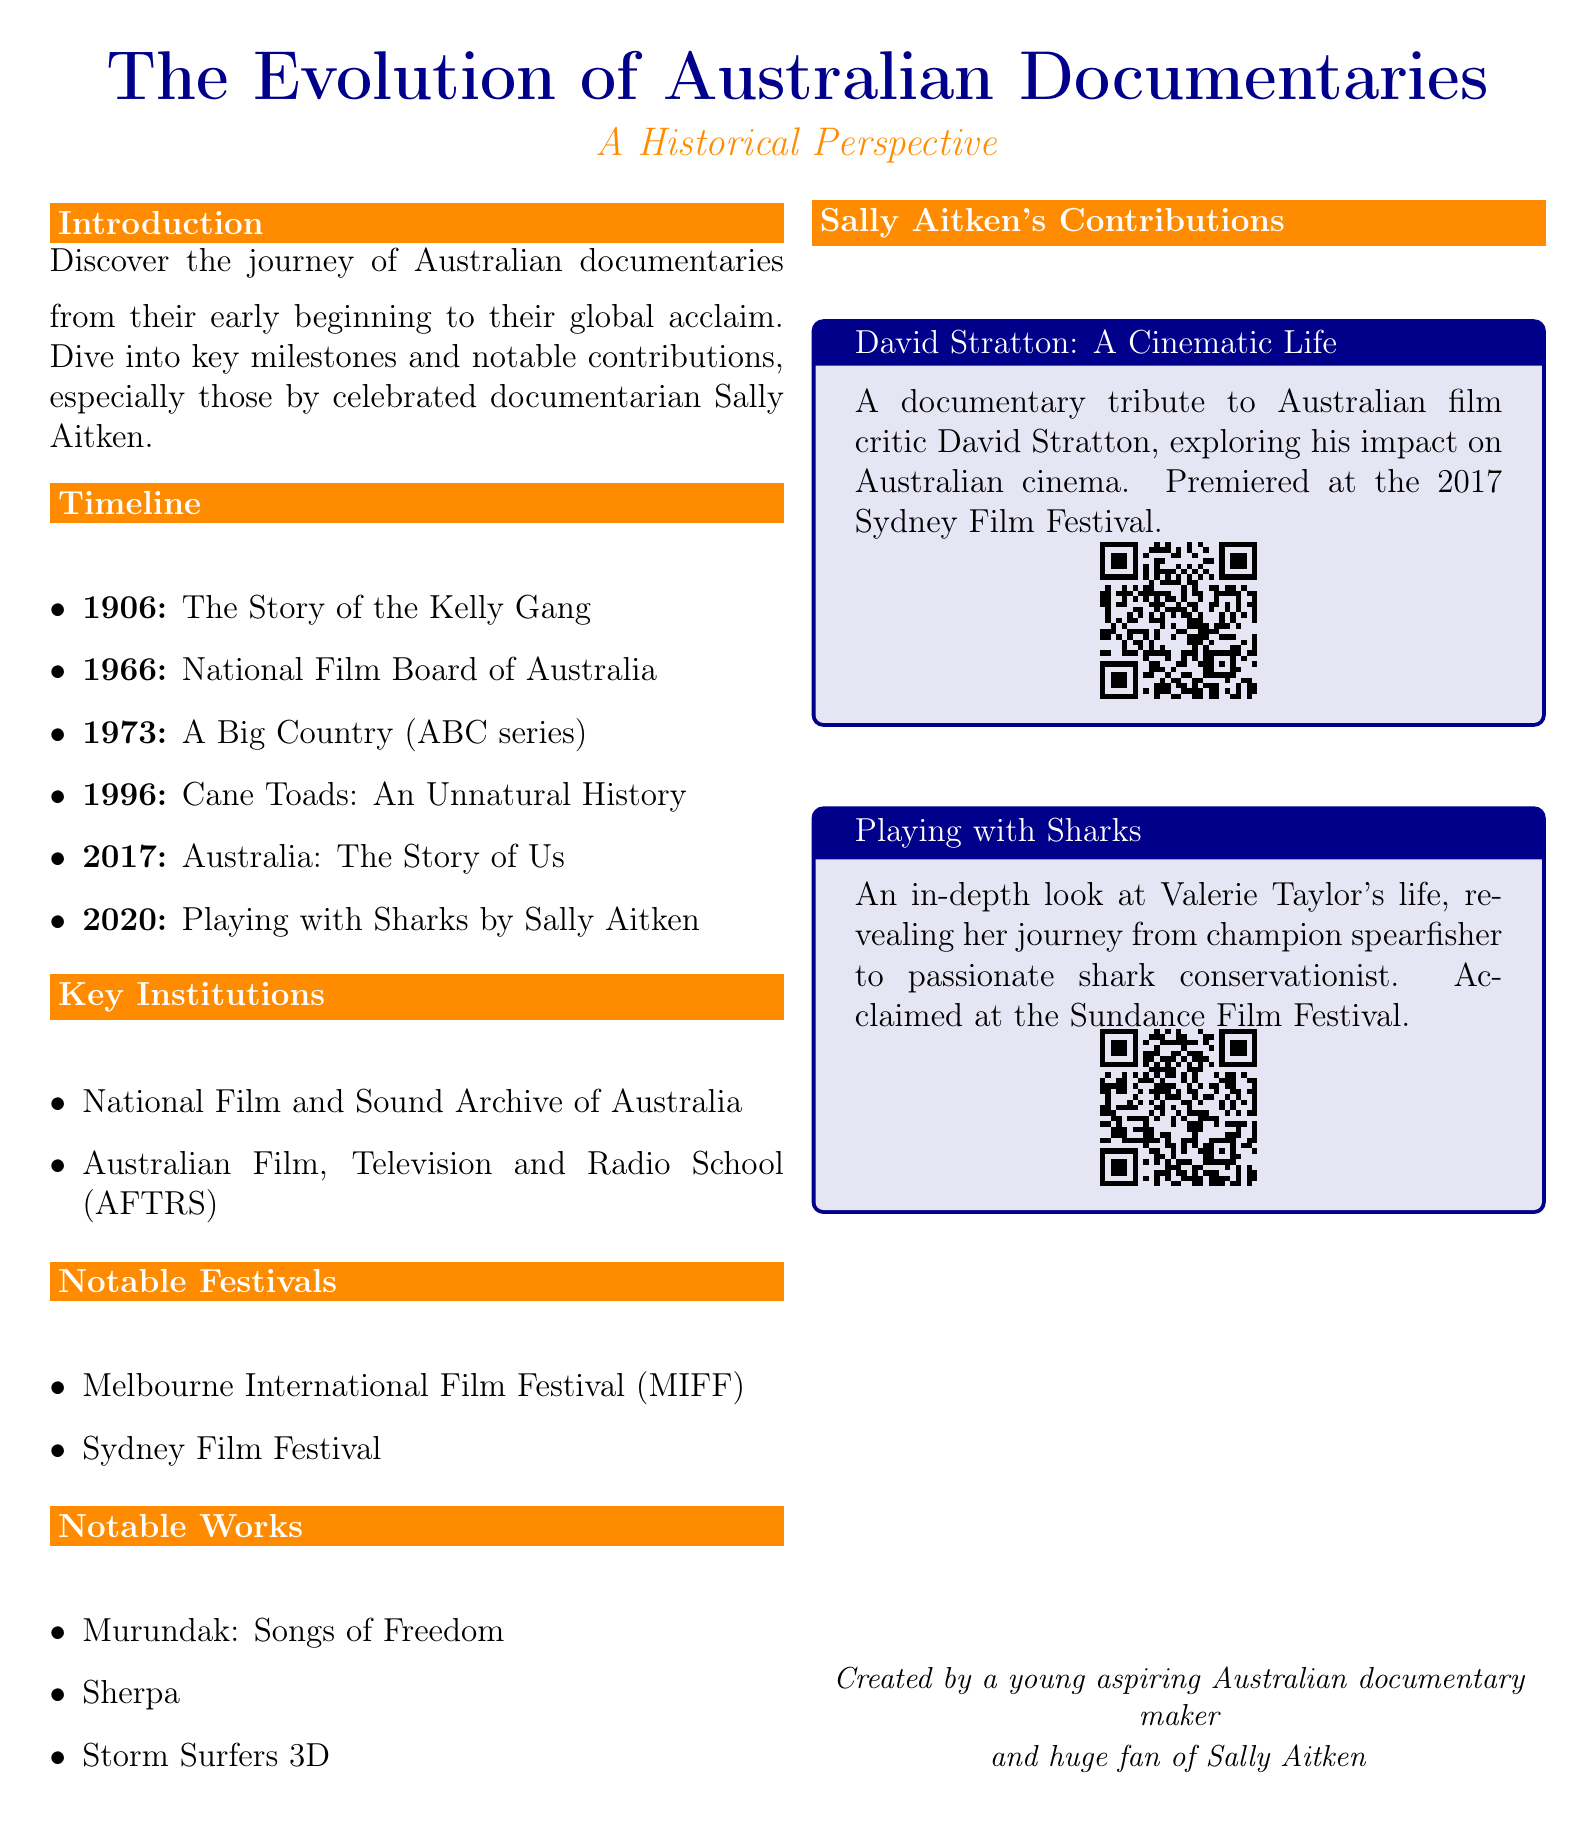What is the first documentary listed in the timeline? The first documentary listed in the timeline is "The Story of the Kelly Gang," which premiered in 1906.
Answer: The Story of the Kelly Gang In which year did Sally Aitken release "Playing with Sharks"? "Playing with Sharks" was released in 2020.
Answer: 2020 What significant institution is mentioned in the document? The National Film and Sound Archive of Australia is one of the key institutions mentioned.
Answer: National Film and Sound Archive of Australia Which film festival premiered the documentary tribute to David Stratton? The documentary tribute to David Stratton premiered at the Sydney Film Festival.
Answer: Sydney Film Festival How many notable festivals are mentioned in the document? Two notable festivals are mentioned: the Melbourne International Film Festival and the Sydney Film Festival.
Answer: Two What is the focus of the documentary "Playing with Sharks"? "Playing with Sharks" focuses on Valerie Taylor's journey from champion spearfisher to shark conservationist.
Answer: Valerie Taylor's journey What color is used for the section titles in the document? The section titles are highlighted using the color Australian orange.
Answer: Australian orange Name one notable work mentioned in the document. "Sherpa" is one of the notable works listed in the document.
Answer: Sherpa 